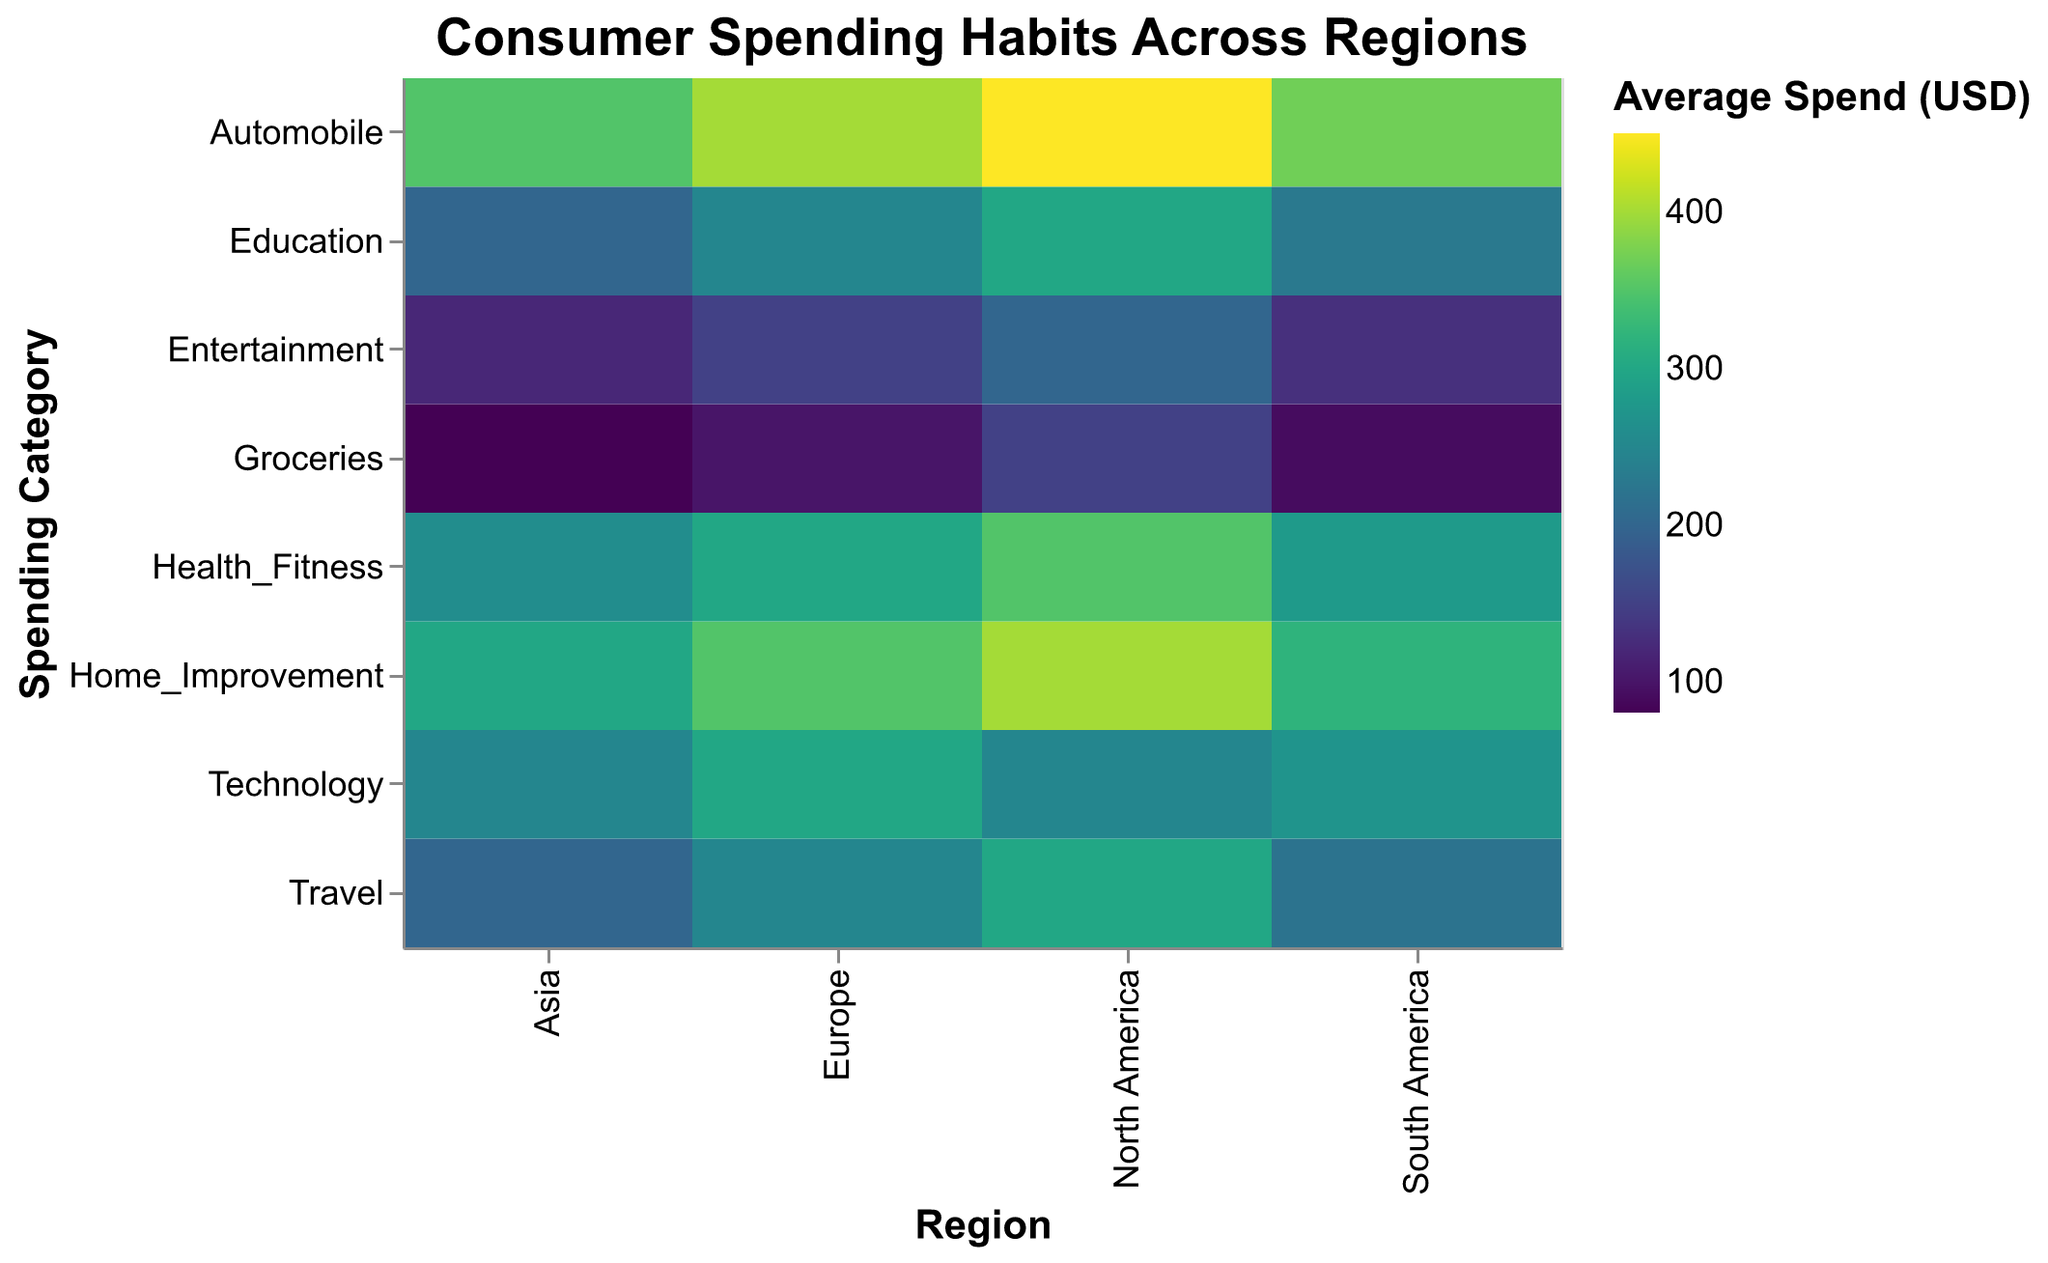What region has the highest average spend in the 'Technology' category? Look for the 'Technology' category on the y-axis, then scan to see which region has the darkest color indicating the highest spend. North America has the highest average spend with 250 USD.
Answer: North America Which age group in Europe spends the most on 'Home_Improvement'? Find 'Europe' on the x-axis and then look for the 'Home_Improvement' category on the y-axis. Check the tooltips for the age group in that intersection. The 35-44 age group spends the most with 350 USD.
Answer: 35-44 Compare the average spend on 'Groceries' between North America and Asia. Locate 'Groceries' on the y-axis and check the cells for 'North America' and 'Asia' on the x-axis. Check their respective colors and tooltips. North America spends 150 USD, while Asia spends 80 USD.
Answer: North America spends more, 150 USD vs 80 USD Which region has the lowest average spend in the 'Automobile' category? Look for the 'Automobile' category on the y-axis, then scan to see which region has the lightest color indicating the lowest spend. Asia has the lowest spend with 350 USD.
Answer: Asia What is the average spend on 'Education' for the 45-54 age group across all regions? Identify the 'Education' category on the y-axis and check the tooltip values for the 45-54 age group in each region ('North America', 'Europe', 'Asia', 'South America'). Summing these values: 300 + 250 + 200 + 230 = 980 USD. Dividing by 4 regions gives an average of 245 USD.
Answer: 245 USD How does the average spend on 'Health_Fitness' in South America compare to North America across all age groups? Identify the 'Health_Fitness' category on the y-axis, then compare values under 'South America' and 'North America'. South America has 280 USD, North America has 350 USD.
Answer: North America spends more, 350 USD vs 280 USD What is the category with the highest average spend in South America? Check the 'South America' column and find the darkest-colored cell which corresponds to the highest spend. The 'Automobile' category has the highest average spend with 370 USD.
Answer: Automobile By how much does the average spend on 'Travel' differ between the 25-34 age group in Europe and Asia? Find the 25-34 age group in the 'Travel' category for both 'Europe' and 'Asia'. Europe spends 250 USD and Asia spends 200 USD. The difference is 250 - 200 = 50 USD.
Answer: 50 USD Which category has a consistent high spend across all regions? Look for a category with darker cells across all regions. The 'Automobile' category shows high spend across all regions.
Answer: Automobile 